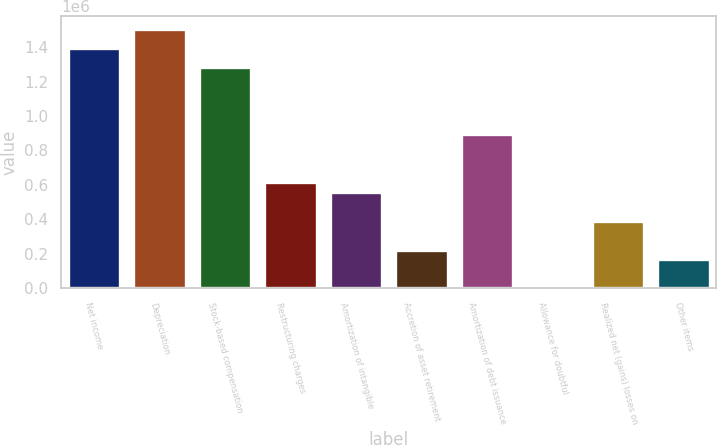<chart> <loc_0><loc_0><loc_500><loc_500><bar_chart><fcel>Net income<fcel>Depreciation<fcel>Stock-based compensation<fcel>Restructuring charges<fcel>Amortization of intangible<fcel>Accretion of asset retirement<fcel>Amortization of debt issuance<fcel>Allowance for doubtful<fcel>Realized net (gains) losses on<fcel>Other items<nl><fcel>1.39542e+06<fcel>1.50706e+06<fcel>1.28379e+06<fcel>613994<fcel>558178<fcel>223280<fcel>893076<fcel>15<fcel>390729<fcel>167464<nl></chart> 